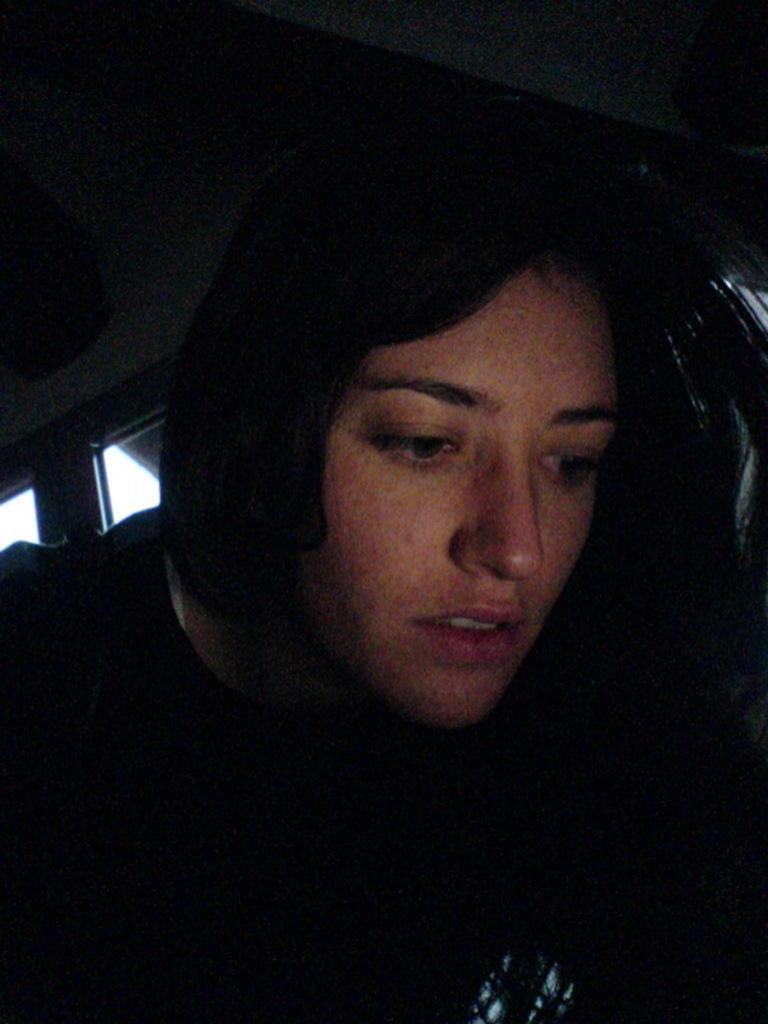Who is the main subject in the image? There is a lady in the image. What is located behind the lady? There is a window behind the lady. What is behind the window? There is a wall behind the window. Can you see any cactus plants near the lady in the image? There is no cactus plant present in the image. 